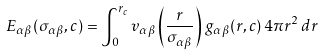<formula> <loc_0><loc_0><loc_500><loc_500>E _ { \alpha \beta } ( \sigma _ { \alpha \beta } , c ) = \int _ { 0 } ^ { r _ { c } } v _ { \alpha \beta } \left ( \frac { r } { \sigma _ { \alpha \beta } } \right ) \, g _ { \alpha \beta } ( r , c ) \, 4 \pi r ^ { 2 } \, d r</formula> 